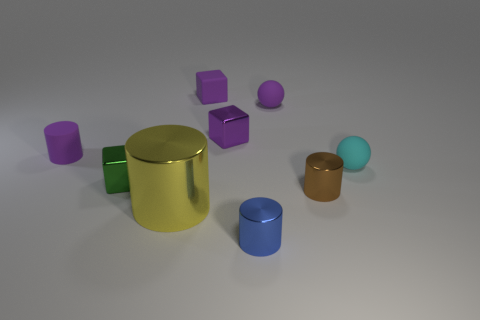Subtract all tiny metal blocks. How many blocks are left? 1 Subtract all blue cylinders. How many cylinders are left? 3 Subtract 1 cubes. How many cubes are left? 2 Add 1 small brown metallic things. How many objects exist? 10 Subtract all cylinders. How many objects are left? 5 Subtract all brown cubes. Subtract all gray spheres. How many cubes are left? 3 Subtract all tiny rubber blocks. Subtract all tiny green shiny blocks. How many objects are left? 7 Add 9 purple matte spheres. How many purple matte spheres are left? 10 Add 7 tiny yellow matte cylinders. How many tiny yellow matte cylinders exist? 7 Subtract 0 green balls. How many objects are left? 9 